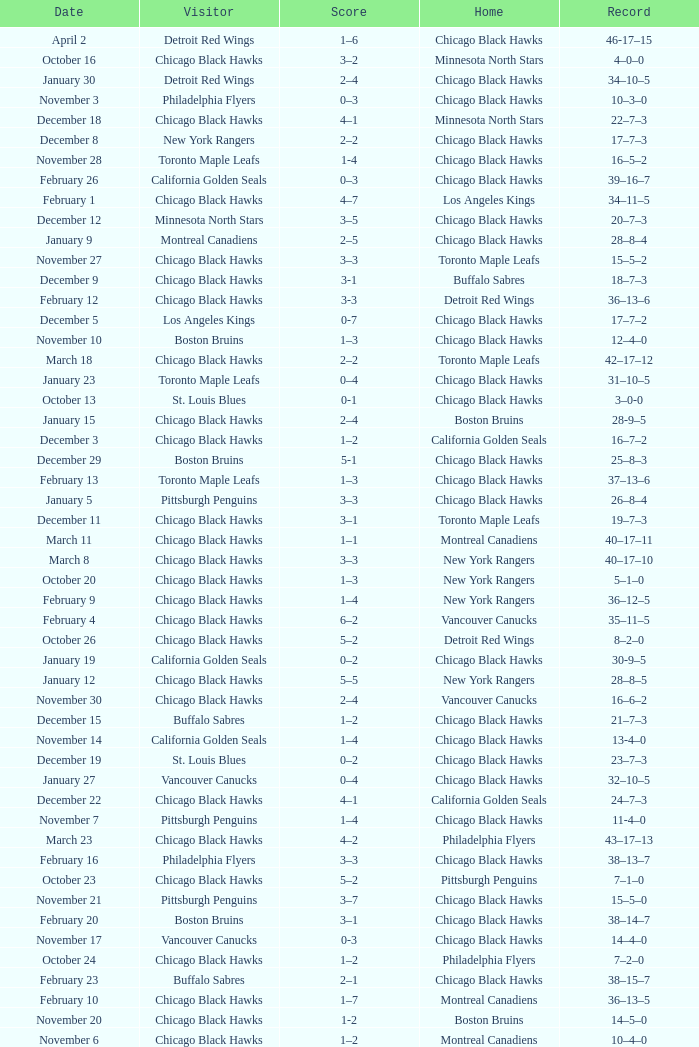What is the Score of the Chicago Black Hawks Home game with the Visiting Vancouver Canucks on November 17? 0-3. 